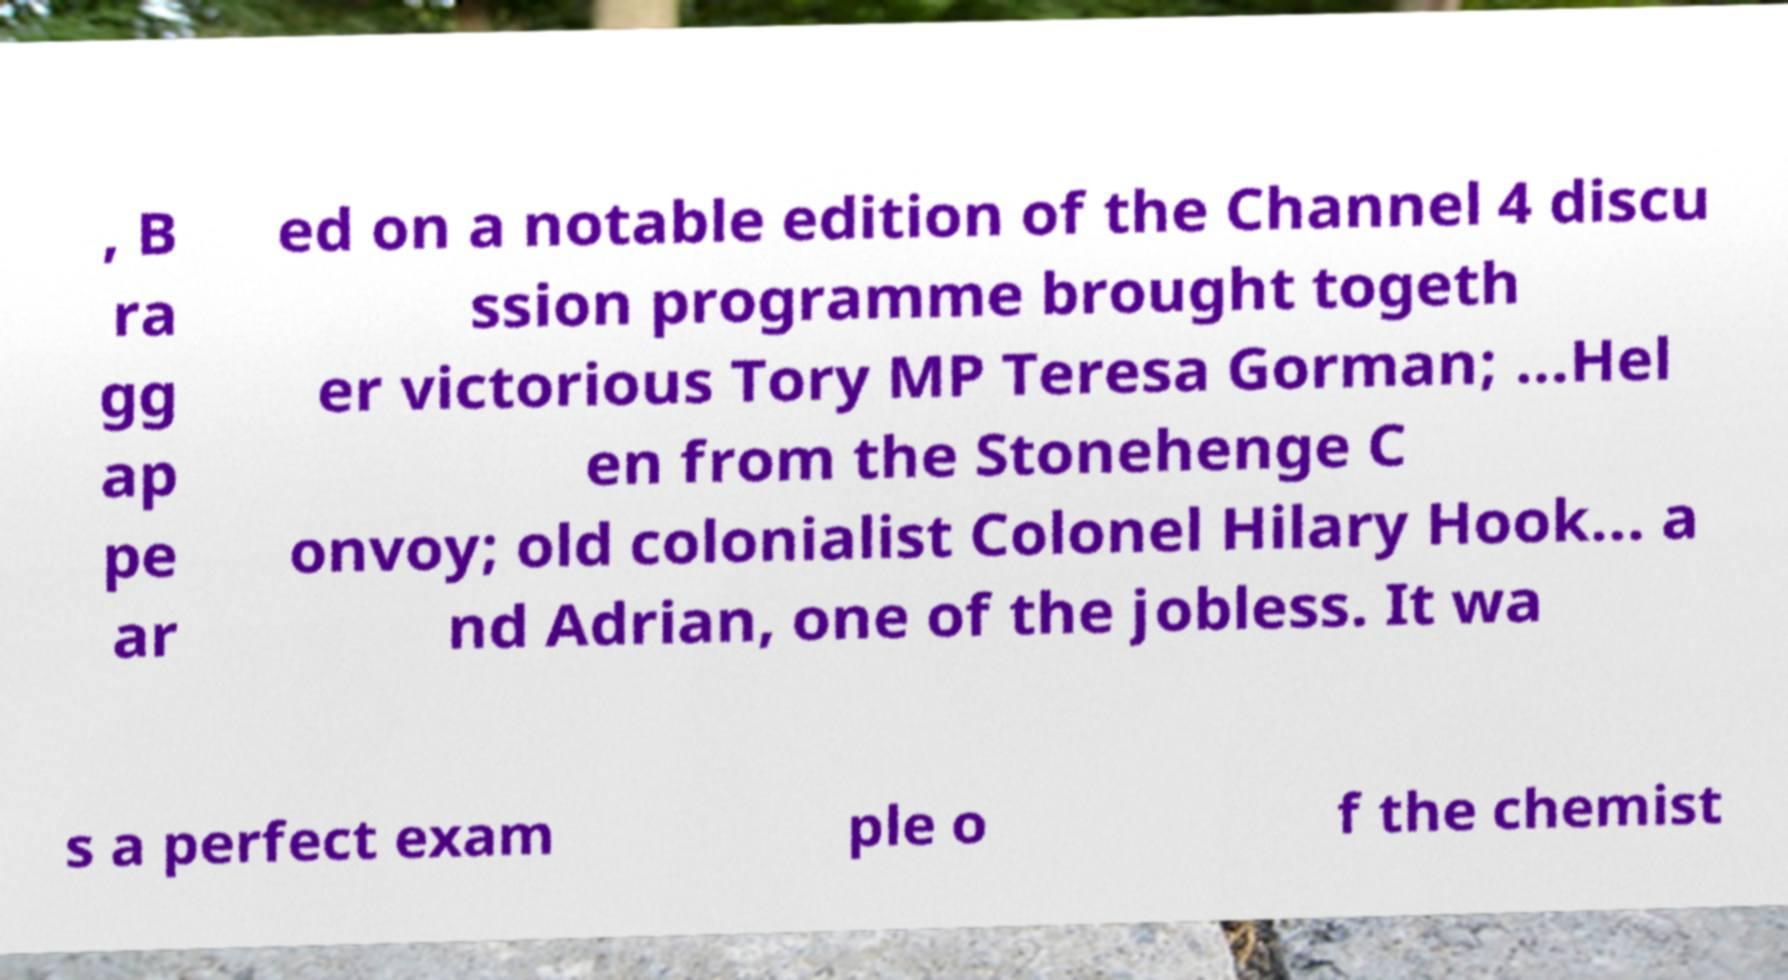What messages or text are displayed in this image? I need them in a readable, typed format. , B ra gg ap pe ar ed on a notable edition of the Channel 4 discu ssion programme brought togeth er victorious Tory MP Teresa Gorman; ...Hel en from the Stonehenge C onvoy; old colonialist Colonel Hilary Hook... a nd Adrian, one of the jobless. It wa s a perfect exam ple o f the chemist 